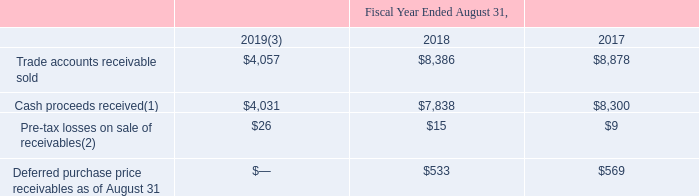In connection with the asset-backed securitization programs, the Company recognized the following (in millions):
(1) The amounts primarily represent proceeds from collections reinvested in revolving-period transfers.
(2) Recorded to other expense within the Consolidated Statements of Operations.
(3) Excludes $650.3 million of trade accounts receivable sold, $488.1 million of cash and $13.9 million of net cash received prior to the amendment of the foreign asset-backed securitization program and under the previous North American asset-backed securitization program.
The asset-backed securitization programs require compliance with several covenants. The North American asset-backed securitization program covenants include compliance with the interest ratio and debt to EBITDA ratio of the five-year unsecured credit facility amended as of November 8, 2017 (“the 2017 Credit Facility”). The foreign asset-backed securitization program covenants include limitations on certain corporate actions such as mergers and consolidations. As of August 31, 2019 and 2018, the Company was in compliance with all covenants under the asset-backed securitization programs.
Which years does the table provide data for trade accounts receivable sold? 2019, 2018, 2017. What were the cash proceeds received in 2019?
Answer scale should be: million. $4,031. What were the Pre-tax losses on sale of receivables in 2018?
Answer scale should be: million. $15. What was the change in Trade accounts receivable sold between 2018 and 2019?
Answer scale should be: million. $4,057-$8,386
Answer: -4329. How many years did cash proceeds received exceed $5,000 million? 2018##2017
Answer: 2. What was the percentage change in Pre-tax losses on sale of receivables between 2017 and 2018?
Answer scale should be: percent. ($15-$9)/$9
Answer: 66.67. 